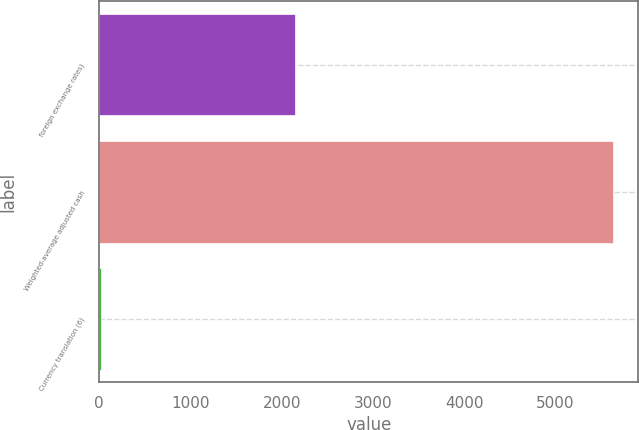Convert chart. <chart><loc_0><loc_0><loc_500><loc_500><bar_chart><fcel>foreign exchange rates)<fcel>Weighted-average adjusted cash<fcel>Currency translation (6)<nl><fcel>2150<fcel>5626.3<fcel>17.9<nl></chart> 